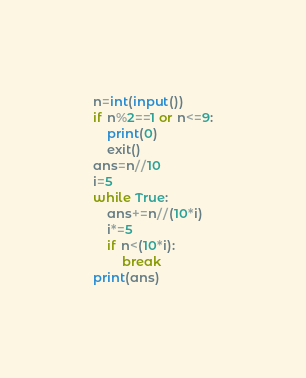<code> <loc_0><loc_0><loc_500><loc_500><_Python_>n=int(input())
if n%2==1 or n<=9:
    print(0)
    exit()
ans=n//10
i=5
while True:
    ans+=n//(10*i)
    i*=5
    if n<(10*i):
        break
print(ans)</code> 